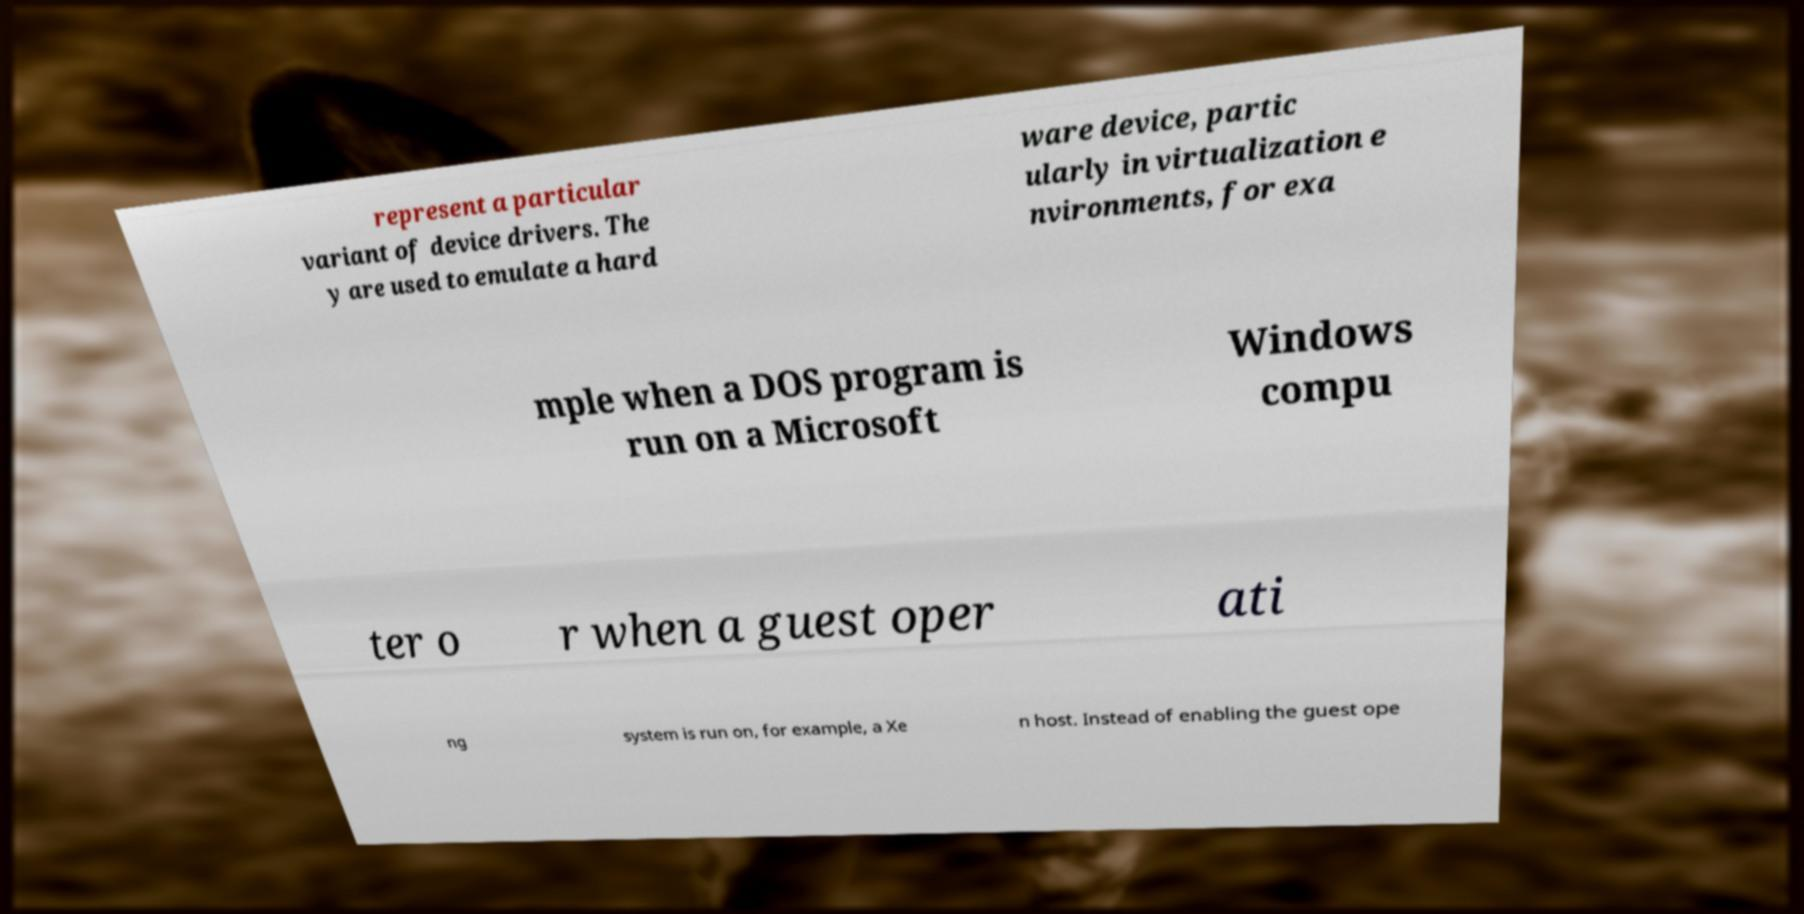Could you assist in decoding the text presented in this image and type it out clearly? represent a particular variant of device drivers. The y are used to emulate a hard ware device, partic ularly in virtualization e nvironments, for exa mple when a DOS program is run on a Microsoft Windows compu ter o r when a guest oper ati ng system is run on, for example, a Xe n host. Instead of enabling the guest ope 